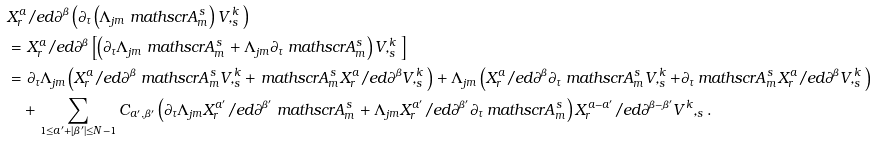<formula> <loc_0><loc_0><loc_500><loc_500>& X _ { r } ^ { a } \slash e d \partial ^ { \beta } \left ( \partial _ { \tau } \left ( \Lambda _ { j m } \ m a t h s c r { A } ^ { s } _ { m } \right ) { V } , _ { s } ^ { k } \right ) \\ & = X _ { r } ^ { a } \slash e d \partial ^ { \beta } \left [ \left ( \partial _ { \tau } \Lambda _ { j m } \ m a t h s c r { A } ^ { s } _ { m } + \Lambda _ { j m } \partial _ { \tau } \ m a t h s c r { A } ^ { s } _ { m } \right ) { V } , _ { s } ^ { k } \right ] \\ & = \partial _ { \tau } \Lambda _ { j m } \left ( X _ { r } ^ { a } \slash e d \partial ^ { \beta } \ m a t h s c r { A } ^ { s } _ { m } { V } , _ { s } ^ { k } + \ m a t h s c r { A } ^ { s } _ { m } X _ { r } ^ { a } \slash e d \partial ^ { \beta } { V } , _ { s } ^ { k } \right ) + \Lambda _ { j m } \left ( X _ { r } ^ { a } \slash e d \partial ^ { \beta } \partial _ { \tau } \ m a t h s c r { A } ^ { s } _ { m } { V } , _ { s } ^ { k } + \partial _ { \tau } \ m a t h s c r { A } ^ { s } _ { m } X _ { r } ^ { a } \slash e d \partial ^ { \beta } { V } , _ { s } ^ { k } \right ) \\ & \quad + \sum _ { 1 \leq a ^ { \prime } + | \beta ^ { \prime } | \leq N - 1 } C _ { a ^ { \prime } , \beta ^ { \prime } } \left ( \partial _ { \tau } \Lambda _ { j m } X _ { r } ^ { a ^ { \prime } } \slash e d \partial ^ { \beta ^ { \prime } } \ m a t h s c r { A } ^ { s } _ { m } + \Lambda _ { j m } X _ { r } ^ { a ^ { \prime } } \slash e d \partial ^ { \beta ^ { \prime } } \partial _ { \tau } \ m a t h s c r { A } ^ { s } _ { m } \right ) X _ { r } ^ { a - a ^ { \prime } } \slash e d \partial ^ { \beta - \beta ^ { \prime } } { V } ^ { k } , _ { s } .</formula> 